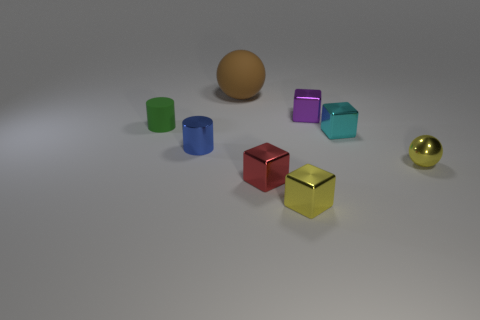Add 1 metallic blocks. How many objects exist? 9 Subtract all spheres. How many objects are left? 6 Subtract all small red metallic objects. Subtract all green matte objects. How many objects are left? 6 Add 7 shiny spheres. How many shiny spheres are left? 8 Add 3 small yellow metal things. How many small yellow metal things exist? 5 Subtract 0 red cylinders. How many objects are left? 8 